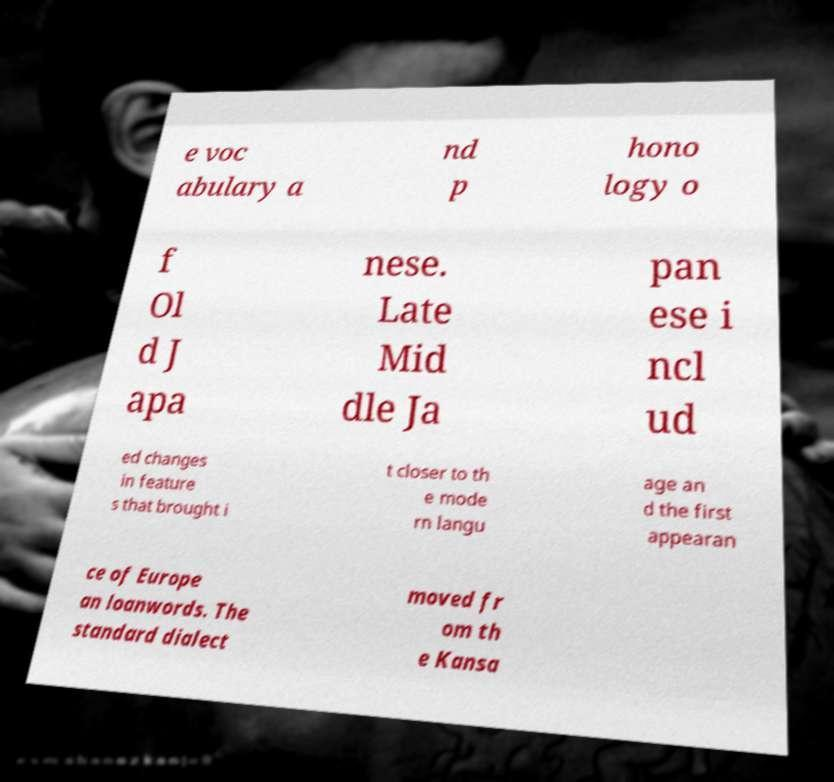Could you extract and type out the text from this image? e voc abulary a nd p hono logy o f Ol d J apa nese. Late Mid dle Ja pan ese i ncl ud ed changes in feature s that brought i t closer to th e mode rn langu age an d the first appearan ce of Europe an loanwords. The standard dialect moved fr om th e Kansa 